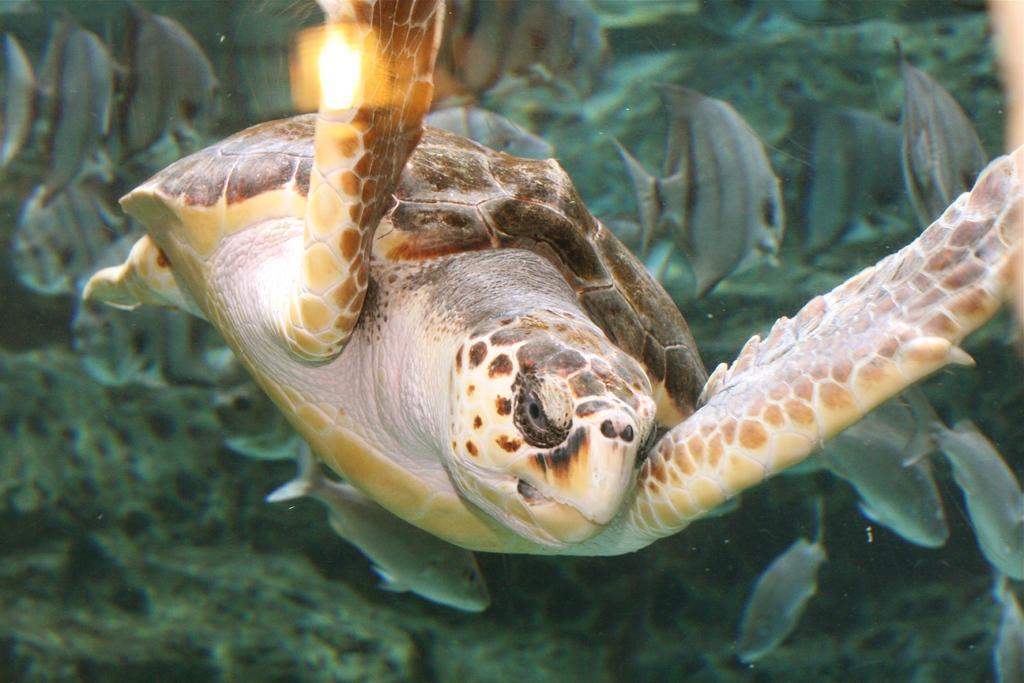Please provide a concise description of this image. In this image I can see a turtle and number of fishes in the background. I can see colour of this turtle is white, cream and brown. 